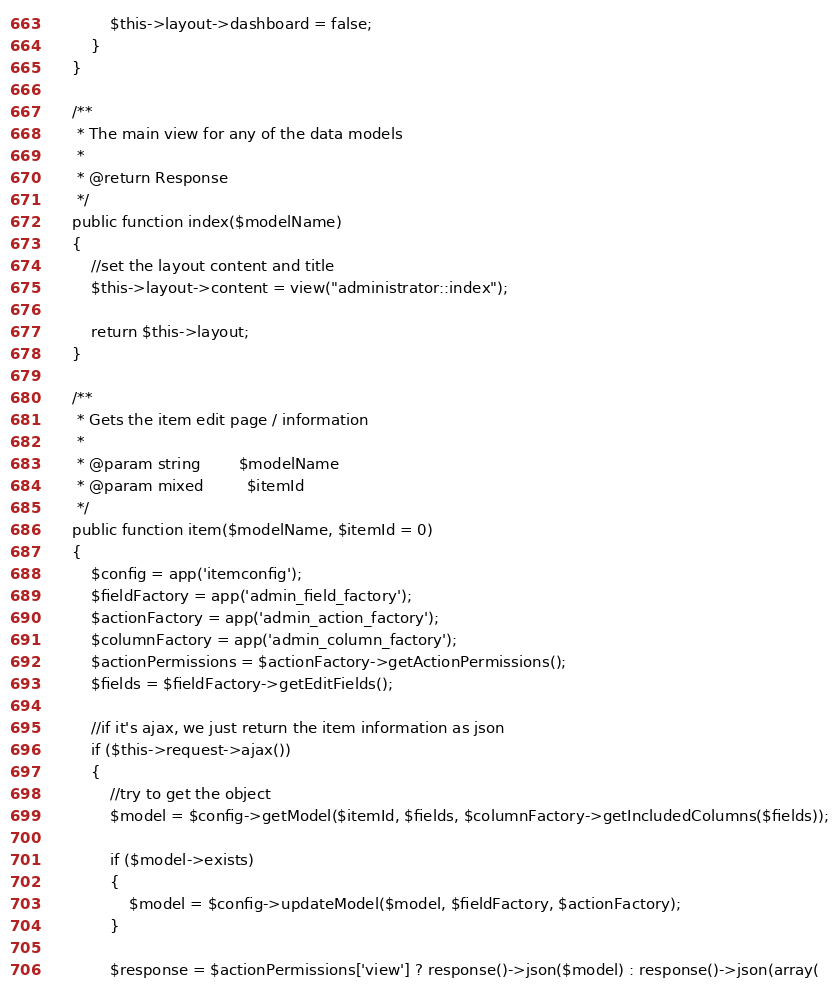Convert code to text. <code><loc_0><loc_0><loc_500><loc_500><_PHP_>			$this->layout->dashboard = false;
		}
	}

	/**
	 * The main view for any of the data models
	 *
	 * @return Response
	 */
	public function index($modelName)
	{
		//set the layout content and title
		$this->layout->content = view("administrator::index");

		return $this->layout;
	}

	/**
	 * Gets the item edit page / information
	 *
	 * @param string		$modelName
	 * @param mixed			$itemId
	 */
	public function item($modelName, $itemId = 0)
	{
		$config = app('itemconfig');
		$fieldFactory = app('admin_field_factory');
		$actionFactory = app('admin_action_factory');
		$columnFactory = app('admin_column_factory');
		$actionPermissions = $actionFactory->getActionPermissions();
		$fields = $fieldFactory->getEditFields();

		//if it's ajax, we just return the item information as json
		if ($this->request->ajax())
		{
			//try to get the object
			$model = $config->getModel($itemId, $fields, $columnFactory->getIncludedColumns($fields));

			if ($model->exists)
			{
				$model = $config->updateModel($model, $fieldFactory, $actionFactory);
			}

			$response = $actionPermissions['view'] ? response()->json($model) : response()->json(array(</code> 